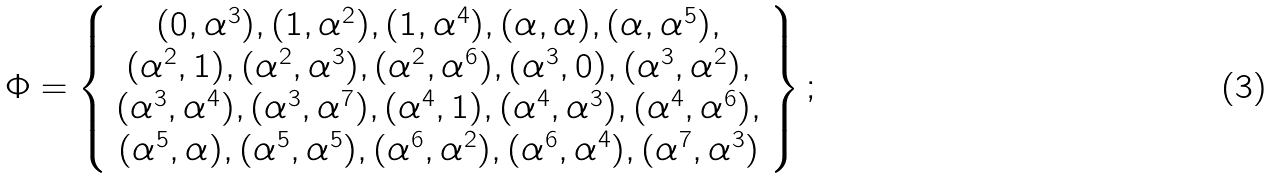Convert formula to latex. <formula><loc_0><loc_0><loc_500><loc_500>\Phi = \left \{ \begin{array} { c } ( 0 , \alpha ^ { 3 } ) , ( 1 , \alpha ^ { 2 } ) , ( 1 , \alpha ^ { 4 } ) , ( \alpha , \alpha ) , ( \alpha , \alpha ^ { 5 } ) , \\ ( \alpha ^ { 2 } , 1 ) , ( \alpha ^ { 2 } , \alpha ^ { 3 } ) , ( \alpha ^ { 2 } , \alpha ^ { 6 } ) , ( \alpha ^ { 3 } , 0 ) , ( \alpha ^ { 3 } , \alpha ^ { 2 } ) , \\ ( \alpha ^ { 3 } , \alpha ^ { 4 } ) , ( \alpha ^ { 3 } , \alpha ^ { 7 } ) , ( \alpha ^ { 4 } , 1 ) , ( \alpha ^ { 4 } , \alpha ^ { 3 } ) , ( \alpha ^ { 4 } , \alpha ^ { 6 } ) , \\ ( \alpha ^ { 5 } , \alpha ) , ( \alpha ^ { 5 } , \alpha ^ { 5 } ) , ( \alpha ^ { 6 } , \alpha ^ { 2 } ) , ( \alpha ^ { 6 } , \alpha ^ { 4 } ) , ( \alpha ^ { 7 } , \alpha ^ { 3 } ) \end{array} \right \} ;</formula> 